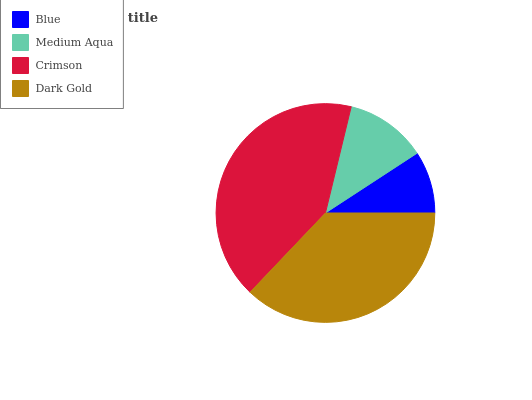Is Blue the minimum?
Answer yes or no. Yes. Is Crimson the maximum?
Answer yes or no. Yes. Is Medium Aqua the minimum?
Answer yes or no. No. Is Medium Aqua the maximum?
Answer yes or no. No. Is Medium Aqua greater than Blue?
Answer yes or no. Yes. Is Blue less than Medium Aqua?
Answer yes or no. Yes. Is Blue greater than Medium Aqua?
Answer yes or no. No. Is Medium Aqua less than Blue?
Answer yes or no. No. Is Dark Gold the high median?
Answer yes or no. Yes. Is Medium Aqua the low median?
Answer yes or no. Yes. Is Blue the high median?
Answer yes or no. No. Is Dark Gold the low median?
Answer yes or no. No. 